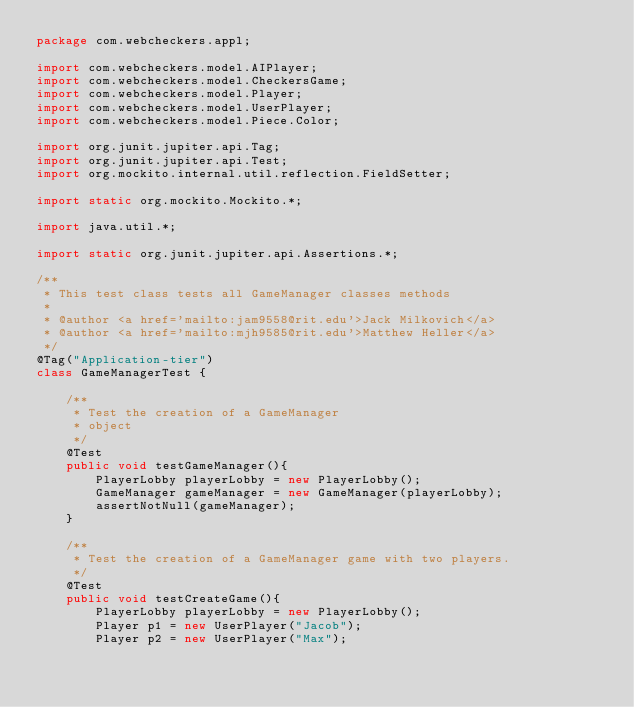Convert code to text. <code><loc_0><loc_0><loc_500><loc_500><_Java_>package com.webcheckers.appl;

import com.webcheckers.model.AIPlayer;
import com.webcheckers.model.CheckersGame;
import com.webcheckers.model.Player;
import com.webcheckers.model.UserPlayer;
import com.webcheckers.model.Piece.Color;

import org.junit.jupiter.api.Tag;
import org.junit.jupiter.api.Test;
import org.mockito.internal.util.reflection.FieldSetter;

import static org.mockito.Mockito.*;

import java.util.*;

import static org.junit.jupiter.api.Assertions.*;

/**
 * This test class tests all GameManager classes methods
 *
 * @author <a href='mailto:jam9558@rit.edu'>Jack Milkovich</a>
 * @author <a href='mailto:mjh9585@rit.edu'>Matthew Heller</a>
 */
@Tag("Application-tier")
class GameManagerTest {

    /**
     * Test the creation of a GameManager
     * object
     */
    @Test
    public void testGameManager(){
        PlayerLobby playerLobby = new PlayerLobby();
        GameManager gameManager = new GameManager(playerLobby);
        assertNotNull(gameManager);
    }

    /**
     * Test the creation of a GameManager game with two players.
     */
    @Test
    public void testCreateGame(){
        PlayerLobby playerLobby = new PlayerLobby();
        Player p1 = new UserPlayer("Jacob");
        Player p2 = new UserPlayer("Max");</code> 